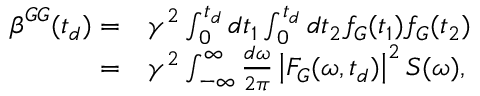Convert formula to latex. <formula><loc_0><loc_0><loc_500><loc_500>\begin{array} { r l } { \beta ^ { G G } ( t _ { d } ) = } & \gamma ^ { 2 } \int _ { 0 } ^ { t _ { d } } d t _ { 1 } \int _ { 0 } ^ { t _ { d } } d t _ { 2 } f _ { G } ( t _ { 1 } ) f _ { G } ( t _ { 2 } ) } \\ { = } & \gamma ^ { 2 } \int _ { \mathbb { - \infty } } ^ { \infty } \frac { d \omega } { 2 \pi } \left | F _ { G } ( \omega , t _ { d } ) \right | ^ { 2 } S ( \omega ) , } \end{array}</formula> 